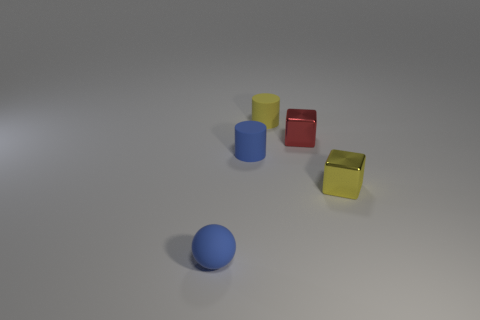There is a thing that is left of the yellow rubber thing and right of the sphere; what is its material?
Give a very brief answer. Rubber. Is the yellow cylinder made of the same material as the tiny thing that is to the right of the tiny red cube?
Offer a very short reply. No. How many other objects are the same color as the small matte ball?
Give a very brief answer. 1. What is the material of the blue thing right of the rubber object that is in front of the yellow metallic cube?
Provide a short and direct response. Rubber. There is a block on the left side of the cube in front of the blue matte object right of the tiny matte sphere; what is its material?
Ensure brevity in your answer.  Metal. Are there more tiny blue cylinders in front of the small ball than big blue spheres?
Give a very brief answer. No. There is a blue cylinder that is the same size as the red block; what is it made of?
Your answer should be very brief. Rubber. Is there a blue object that has the same size as the red shiny cube?
Offer a very short reply. Yes. There is a yellow thing that is in front of the small yellow cylinder; what size is it?
Provide a succinct answer. Small. The red object has what size?
Provide a short and direct response. Small. 